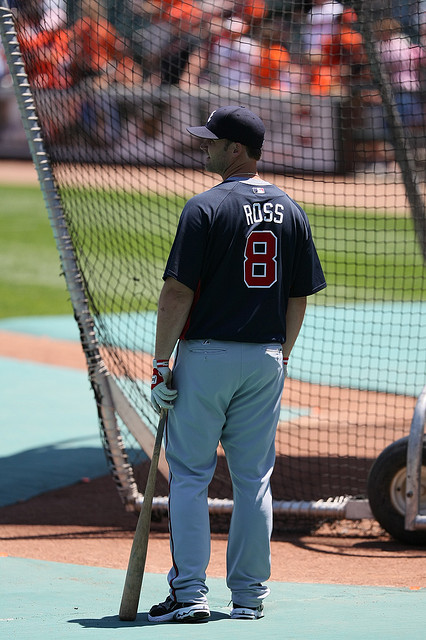Identify the text contained in this image. ROSS 8 